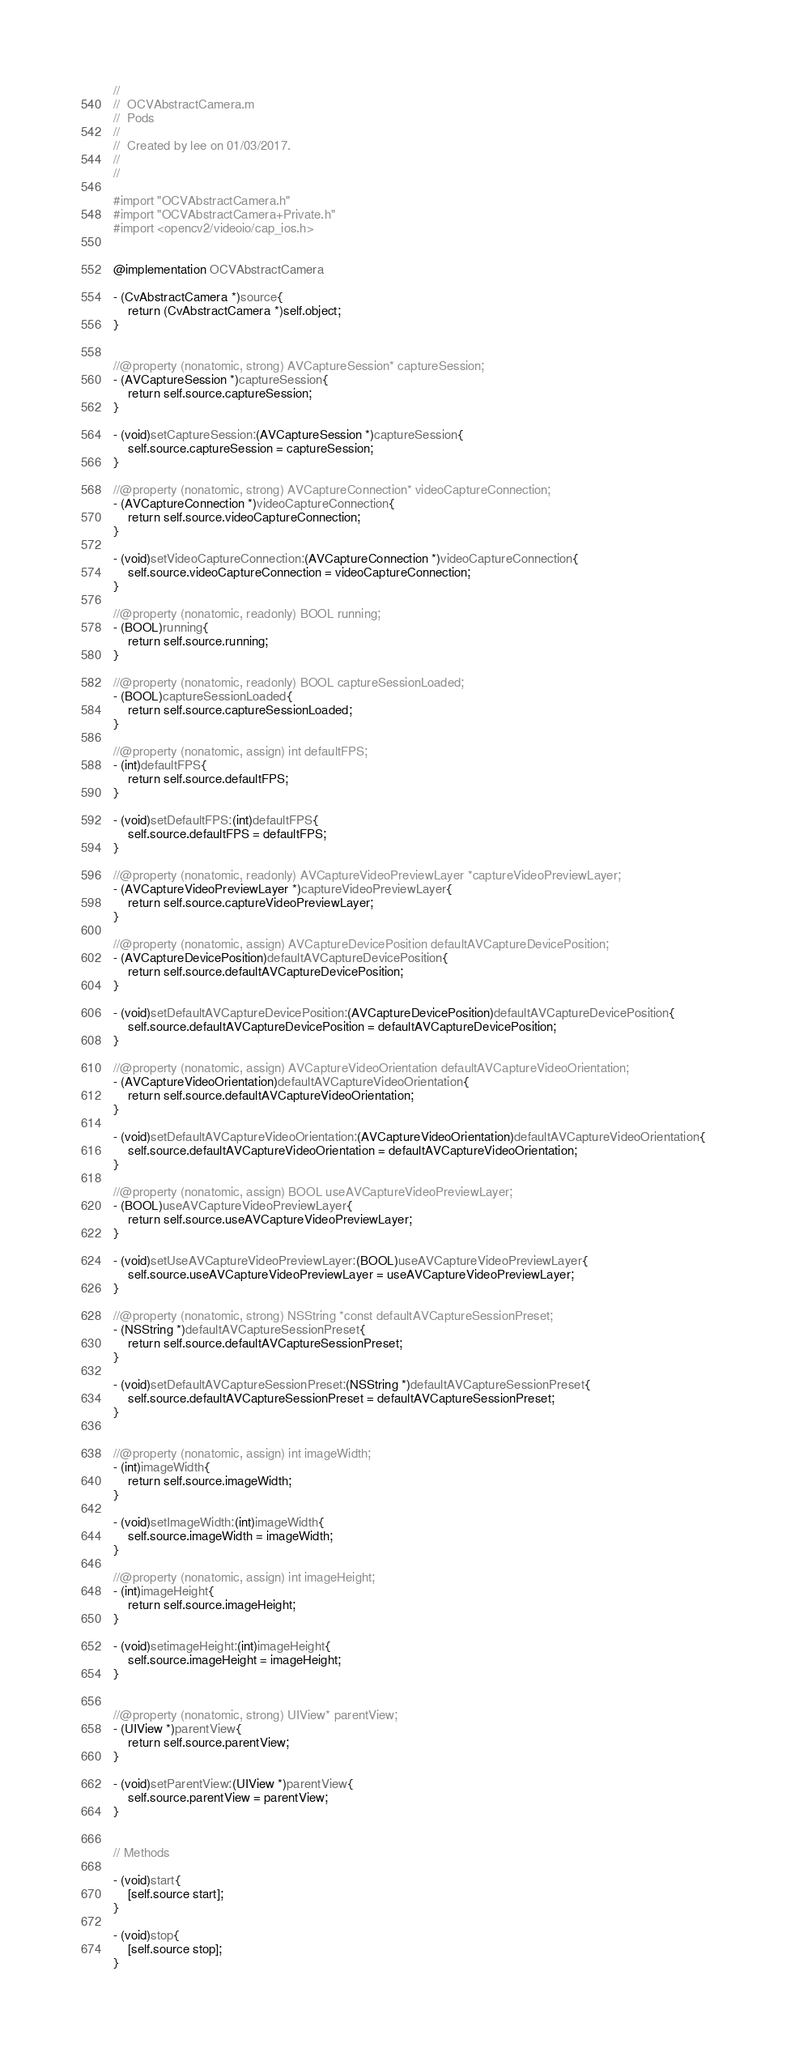Convert code to text. <code><loc_0><loc_0><loc_500><loc_500><_ObjectiveC_>//
//  OCVAbstractCamera.m
//  Pods
//
//  Created by lee on 01/03/2017.
//
//

#import "OCVAbstractCamera.h"
#import "OCVAbstractCamera+Private.h"
#import <opencv2/videoio/cap_ios.h>


@implementation OCVAbstractCamera

- (CvAbstractCamera *)source{
    return (CvAbstractCamera *)self.object;
}


//@property (nonatomic, strong) AVCaptureSession* captureSession;
- (AVCaptureSession *)captureSession{
    return self.source.captureSession;
}

- (void)setCaptureSession:(AVCaptureSession *)captureSession{
    self.source.captureSession = captureSession;
}

//@property (nonatomic, strong) AVCaptureConnection* videoCaptureConnection;
- (AVCaptureConnection *)videoCaptureConnection{
    return self.source.videoCaptureConnection;
}

- (void)setVideoCaptureConnection:(AVCaptureConnection *)videoCaptureConnection{
    self.source.videoCaptureConnection = videoCaptureConnection;
}

//@property (nonatomic, readonly) BOOL running;
- (BOOL)running{
    return self.source.running;
}

//@property (nonatomic, readonly) BOOL captureSessionLoaded;
- (BOOL)captureSessionLoaded{
    return self.source.captureSessionLoaded;
}

//@property (nonatomic, assign) int defaultFPS;
- (int)defaultFPS{
    return self.source.defaultFPS;
}

- (void)setDefaultFPS:(int)defaultFPS{
    self.source.defaultFPS = defaultFPS;
}

//@property (nonatomic, readonly) AVCaptureVideoPreviewLayer *captureVideoPreviewLayer;
- (AVCaptureVideoPreviewLayer *)captureVideoPreviewLayer{
    return self.source.captureVideoPreviewLayer;
}

//@property (nonatomic, assign) AVCaptureDevicePosition defaultAVCaptureDevicePosition;
- (AVCaptureDevicePosition)defaultAVCaptureDevicePosition{
    return self.source.defaultAVCaptureDevicePosition;
}

- (void)setDefaultAVCaptureDevicePosition:(AVCaptureDevicePosition)defaultAVCaptureDevicePosition{
    self.source.defaultAVCaptureDevicePosition = defaultAVCaptureDevicePosition;
}

//@property (nonatomic, assign) AVCaptureVideoOrientation defaultAVCaptureVideoOrientation;
- (AVCaptureVideoOrientation)defaultAVCaptureVideoOrientation{
    return self.source.defaultAVCaptureVideoOrientation;
}

- (void)setDefaultAVCaptureVideoOrientation:(AVCaptureVideoOrientation)defaultAVCaptureVideoOrientation{
    self.source.defaultAVCaptureVideoOrientation = defaultAVCaptureVideoOrientation;
}

//@property (nonatomic, assign) BOOL useAVCaptureVideoPreviewLayer;
- (BOOL)useAVCaptureVideoPreviewLayer{
    return self.source.useAVCaptureVideoPreviewLayer;
}

- (void)setUseAVCaptureVideoPreviewLayer:(BOOL)useAVCaptureVideoPreviewLayer{
    self.source.useAVCaptureVideoPreviewLayer = useAVCaptureVideoPreviewLayer;
}

//@property (nonatomic, strong) NSString *const defaultAVCaptureSessionPreset;
- (NSString *)defaultAVCaptureSessionPreset{
    return self.source.defaultAVCaptureSessionPreset;
}

- (void)setDefaultAVCaptureSessionPreset:(NSString *)defaultAVCaptureSessionPreset{
    self.source.defaultAVCaptureSessionPreset = defaultAVCaptureSessionPreset;
}


//@property (nonatomic, assign) int imageWidth;
- (int)imageWidth{
    return self.source.imageWidth;
}

- (void)setImageWidth:(int)imageWidth{
    self.source.imageWidth = imageWidth;
}

//@property (nonatomic, assign) int imageHeight;
- (int)imageHeight{
    return self.source.imageHeight;
}

- (void)setimageHeight:(int)imageHeight{
    self.source.imageHeight = imageHeight;
}


//@property (nonatomic, strong) UIView* parentView;
- (UIView *)parentView{
    return self.source.parentView;
}

- (void)setParentView:(UIView *)parentView{
    self.source.parentView = parentView;
}


// Methods

- (void)start{
    [self.source start];
}

- (void)stop{
    [self.source stop];
}
</code> 